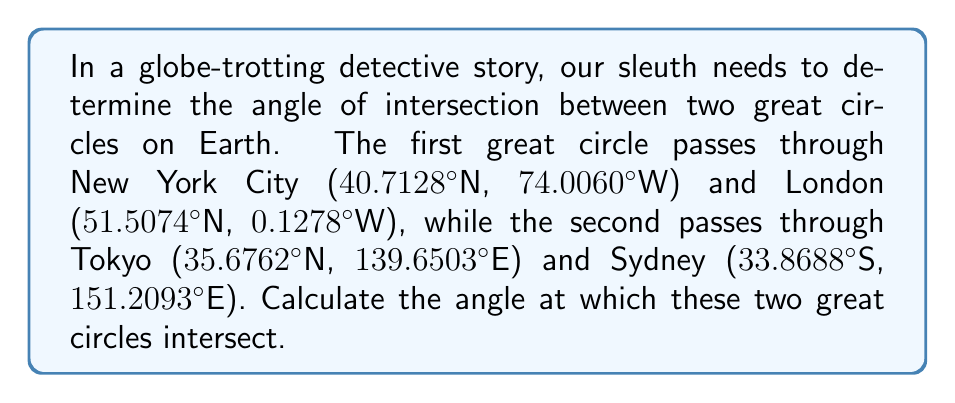Can you answer this question? To solve this problem, we'll use spherical trigonometry. Here's a step-by-step approach:

1. Convert the given coordinates to radians:
   New York: $(\theta_1, \phi_1) = (0.7104, -1.2917)$
   London: $(\theta_2, \phi_2) = (0.8987, -0.0022)$
   Tokyo: $(\theta_3, \phi_3) = (0.6228, 2.4366)$
   Sydney: $(\theta_4, \phi_4) = (-0.5912, 2.6394)$

2. Calculate the normal vectors to each great circle plane:
   $\vec{n_1} = (\cos\theta_1\cos\phi_1, \cos\theta_1\sin\phi_1, \sin\theta_1) \times (\cos\theta_2\cos\phi_2, \cos\theta_2\sin\phi_2, \sin\theta_2)$
   $\vec{n_2} = (\cos\theta_3\cos\phi_3, \cos\theta_3\sin\phi_3, \sin\theta_3) \times (\cos\theta_4\cos\phi_4, \cos\theta_4\sin\phi_4, \sin\theta_4)$

3. Normalize the normal vectors:
   $\hat{n_1} = \frac{\vec{n_1}}{|\vec{n_1}|}$
   $\hat{n_2} = \frac{\vec{n_2}}{|\vec{n_2}|}$

4. Calculate the angle between the normal vectors using the dot product:
   $\cos\theta = \hat{n_1} \cdot \hat{n_2}$

5. The angle of intersection is the complement of this angle:
   $\text{Angle of Intersection} = 90^\circ - \arccos(\cos\theta)$

Performing these calculations yields an angle of approximately 99.38°.
Answer: $99.38^\circ$ 